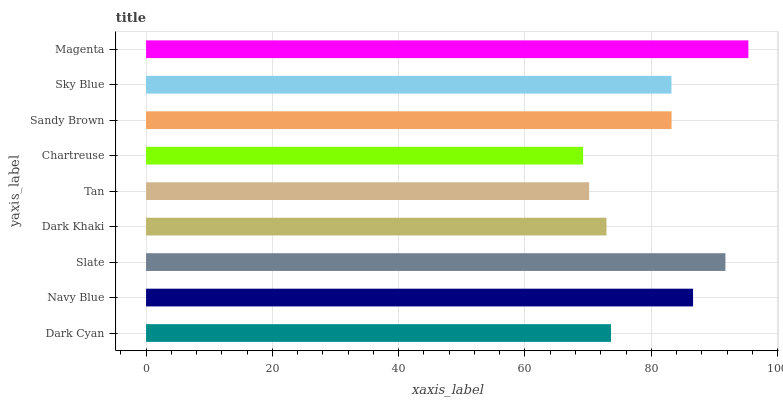Is Chartreuse the minimum?
Answer yes or no. Yes. Is Magenta the maximum?
Answer yes or no. Yes. Is Navy Blue the minimum?
Answer yes or no. No. Is Navy Blue the maximum?
Answer yes or no. No. Is Navy Blue greater than Dark Cyan?
Answer yes or no. Yes. Is Dark Cyan less than Navy Blue?
Answer yes or no. Yes. Is Dark Cyan greater than Navy Blue?
Answer yes or no. No. Is Navy Blue less than Dark Cyan?
Answer yes or no. No. Is Sky Blue the high median?
Answer yes or no. Yes. Is Sky Blue the low median?
Answer yes or no. Yes. Is Slate the high median?
Answer yes or no. No. Is Sandy Brown the low median?
Answer yes or no. No. 